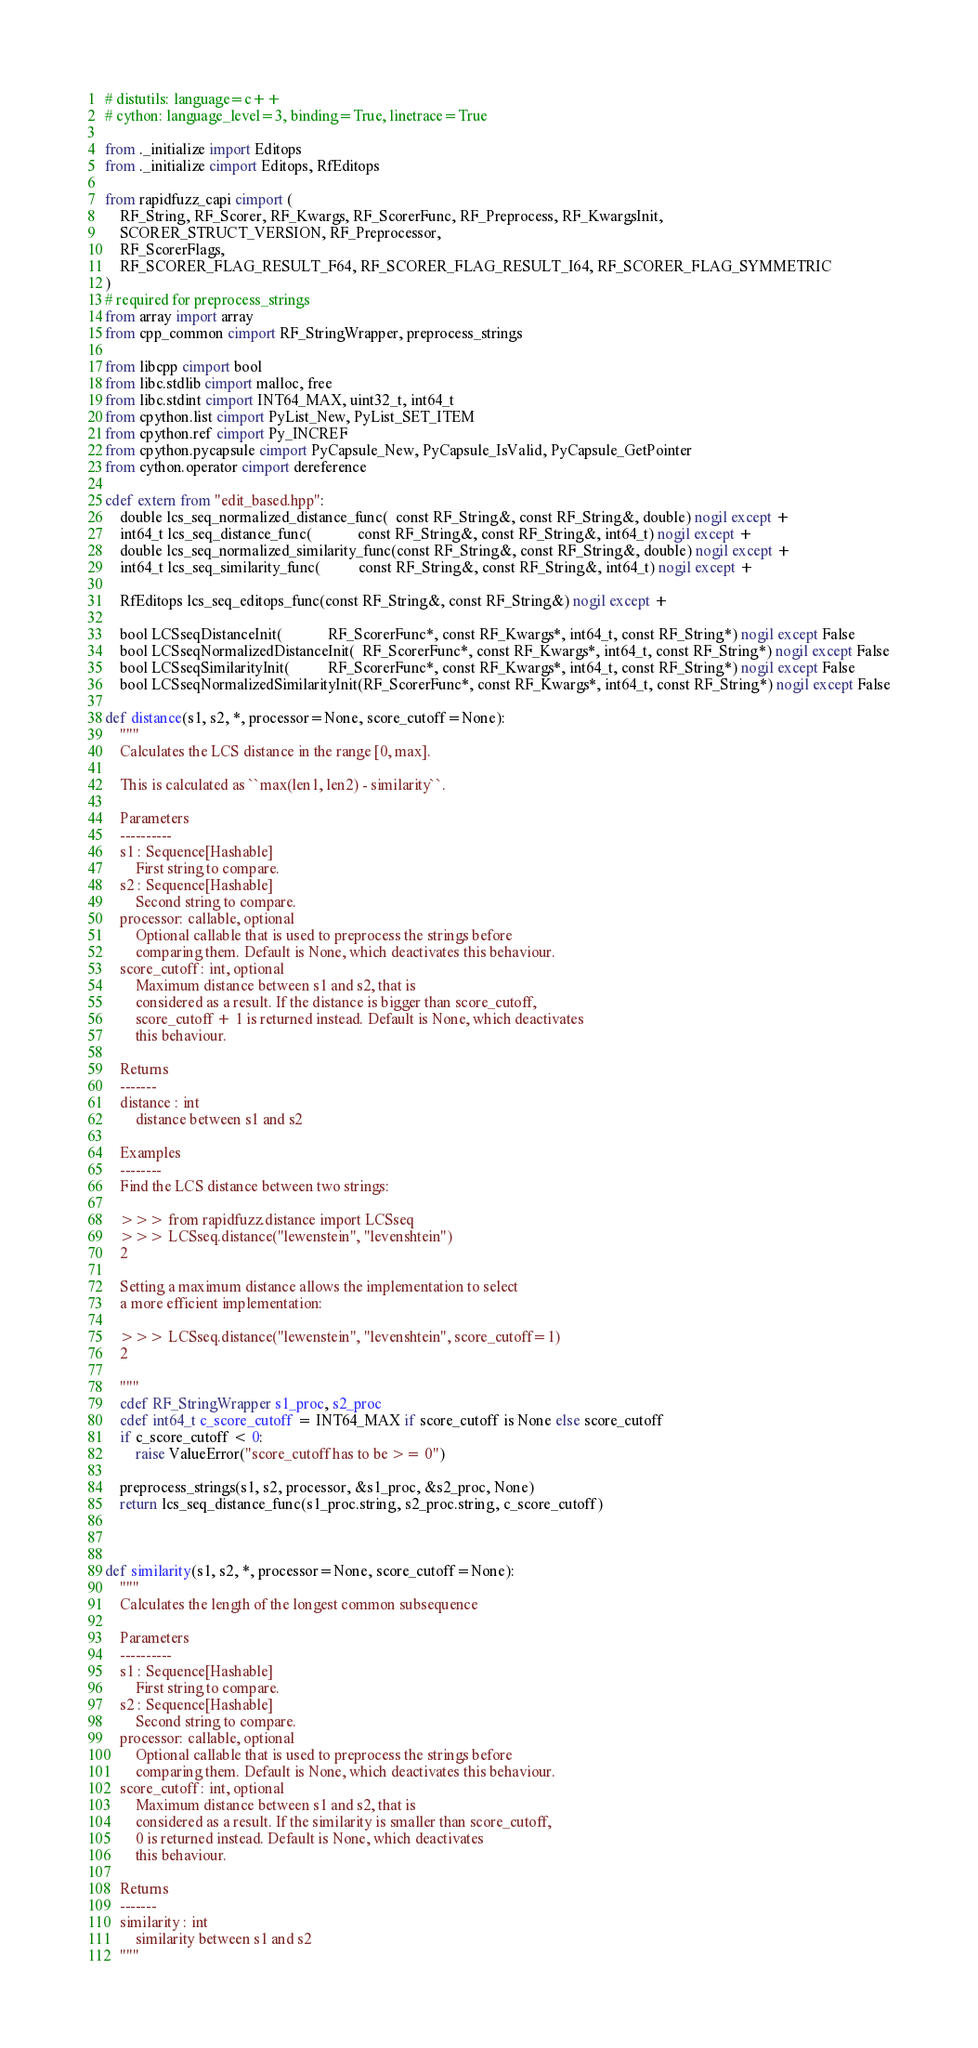<code> <loc_0><loc_0><loc_500><loc_500><_Cython_># distutils: language=c++
# cython: language_level=3, binding=True, linetrace=True

from ._initialize import Editops
from ._initialize cimport Editops, RfEditops

from rapidfuzz_capi cimport (
    RF_String, RF_Scorer, RF_Kwargs, RF_ScorerFunc, RF_Preprocess, RF_KwargsInit,
    SCORER_STRUCT_VERSION, RF_Preprocessor,
    RF_ScorerFlags,
    RF_SCORER_FLAG_RESULT_F64, RF_SCORER_FLAG_RESULT_I64, RF_SCORER_FLAG_SYMMETRIC
)
# required for preprocess_strings
from array import array
from cpp_common cimport RF_StringWrapper, preprocess_strings

from libcpp cimport bool
from libc.stdlib cimport malloc, free
from libc.stdint cimport INT64_MAX, uint32_t, int64_t
from cpython.list cimport PyList_New, PyList_SET_ITEM
from cpython.ref cimport Py_INCREF
from cpython.pycapsule cimport PyCapsule_New, PyCapsule_IsValid, PyCapsule_GetPointer
from cython.operator cimport dereference

cdef extern from "edit_based.hpp":
    double lcs_seq_normalized_distance_func(  const RF_String&, const RF_String&, double) nogil except +
    int64_t lcs_seq_distance_func(            const RF_String&, const RF_String&, int64_t) nogil except +
    double lcs_seq_normalized_similarity_func(const RF_String&, const RF_String&, double) nogil except +
    int64_t lcs_seq_similarity_func(          const RF_String&, const RF_String&, int64_t) nogil except +

    RfEditops lcs_seq_editops_func(const RF_String&, const RF_String&) nogil except +

    bool LCSseqDistanceInit(            RF_ScorerFunc*, const RF_Kwargs*, int64_t, const RF_String*) nogil except False
    bool LCSseqNormalizedDistanceInit(  RF_ScorerFunc*, const RF_Kwargs*, int64_t, const RF_String*) nogil except False
    bool LCSseqSimilarityInit(          RF_ScorerFunc*, const RF_Kwargs*, int64_t, const RF_String*) nogil except False
    bool LCSseqNormalizedSimilarityInit(RF_ScorerFunc*, const RF_Kwargs*, int64_t, const RF_String*) nogil except False

def distance(s1, s2, *, processor=None, score_cutoff=None):
    """
    Calculates the LCS distance in the range [0, max].

    This is calculated as ``max(len1, len2) - similarity``.

    Parameters
    ----------
    s1 : Sequence[Hashable]
        First string to compare.
    s2 : Sequence[Hashable]
        Second string to compare.
    processor: callable, optional
        Optional callable that is used to preprocess the strings before
        comparing them. Default is None, which deactivates this behaviour.
    score_cutoff : int, optional
        Maximum distance between s1 and s2, that is
        considered as a result. If the distance is bigger than score_cutoff,
        score_cutoff + 1 is returned instead. Default is None, which deactivates
        this behaviour.

    Returns
    -------
    distance : int
        distance between s1 and s2

    Examples
    --------
    Find the LCS distance between two strings:

    >>> from rapidfuzz.distance import LCSseq
    >>> LCSseq.distance("lewenstein", "levenshtein")
    2

    Setting a maximum distance allows the implementation to select
    a more efficient implementation:

    >>> LCSseq.distance("lewenstein", "levenshtein", score_cutoff=1)
    2

    """
    cdef RF_StringWrapper s1_proc, s2_proc
    cdef int64_t c_score_cutoff = INT64_MAX if score_cutoff is None else score_cutoff
    if c_score_cutoff < 0:
        raise ValueError("score_cutoff has to be >= 0")

    preprocess_strings(s1, s2, processor, &s1_proc, &s2_proc, None)
    return lcs_seq_distance_func(s1_proc.string, s2_proc.string, c_score_cutoff)



def similarity(s1, s2, *, processor=None, score_cutoff=None):
    """
    Calculates the length of the longest common subsequence

    Parameters
    ----------
    s1 : Sequence[Hashable]
        First string to compare.
    s2 : Sequence[Hashable]
        Second string to compare.
    processor: callable, optional
        Optional callable that is used to preprocess the strings before
        comparing them. Default is None, which deactivates this behaviour.
    score_cutoff : int, optional
        Maximum distance between s1 and s2, that is
        considered as a result. If the similarity is smaller than score_cutoff,
        0 is returned instead. Default is None, which deactivates
        this behaviour.

    Returns
    -------
    similarity : int
        similarity between s1 and s2
    """</code> 